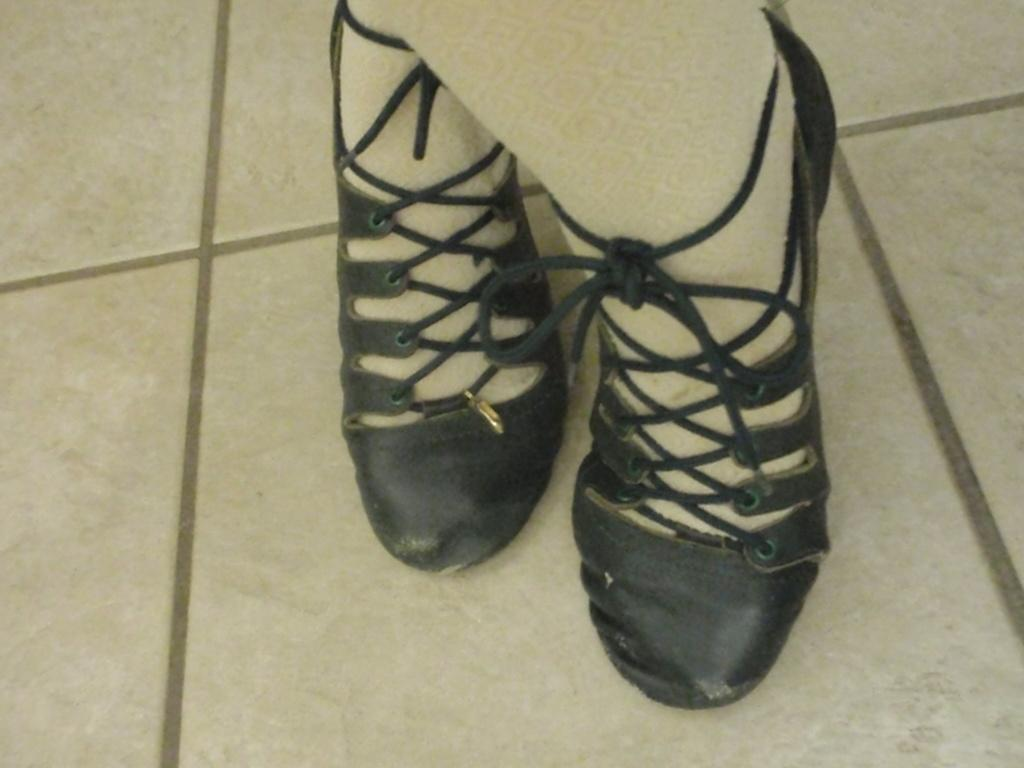What part of a person is visible in the image? There are a person's legs visible in the image. What type of clothing is the person wearing on their feet? The person is wearing footwear in the image. What color is the background of the image? The background of the image is cream-colored. How many ants can be seen crawling on the person's legs in the image? There are no ants visible in the image; only the person's legs and footwear are present. 